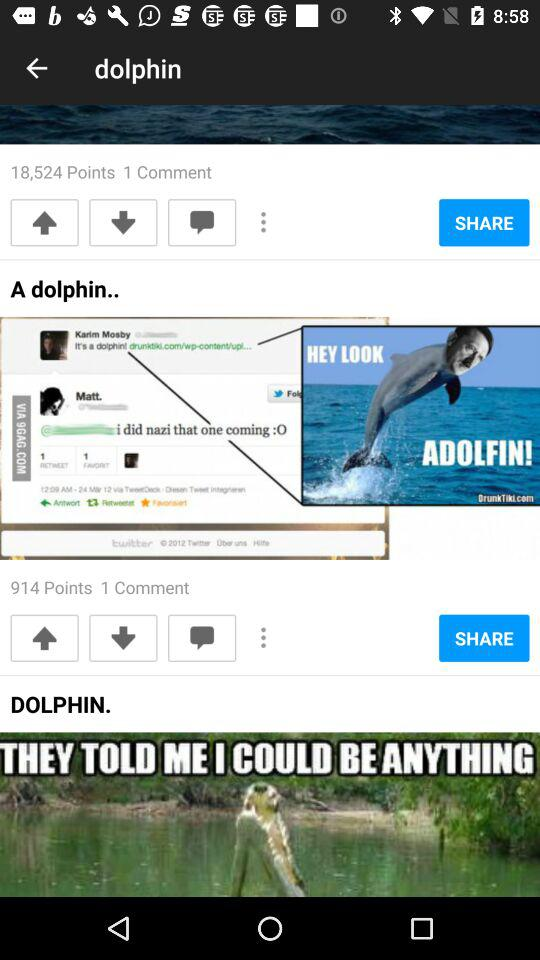How many points are there of "A dolphin" post? There are 914 points of "A dolphin" post. 